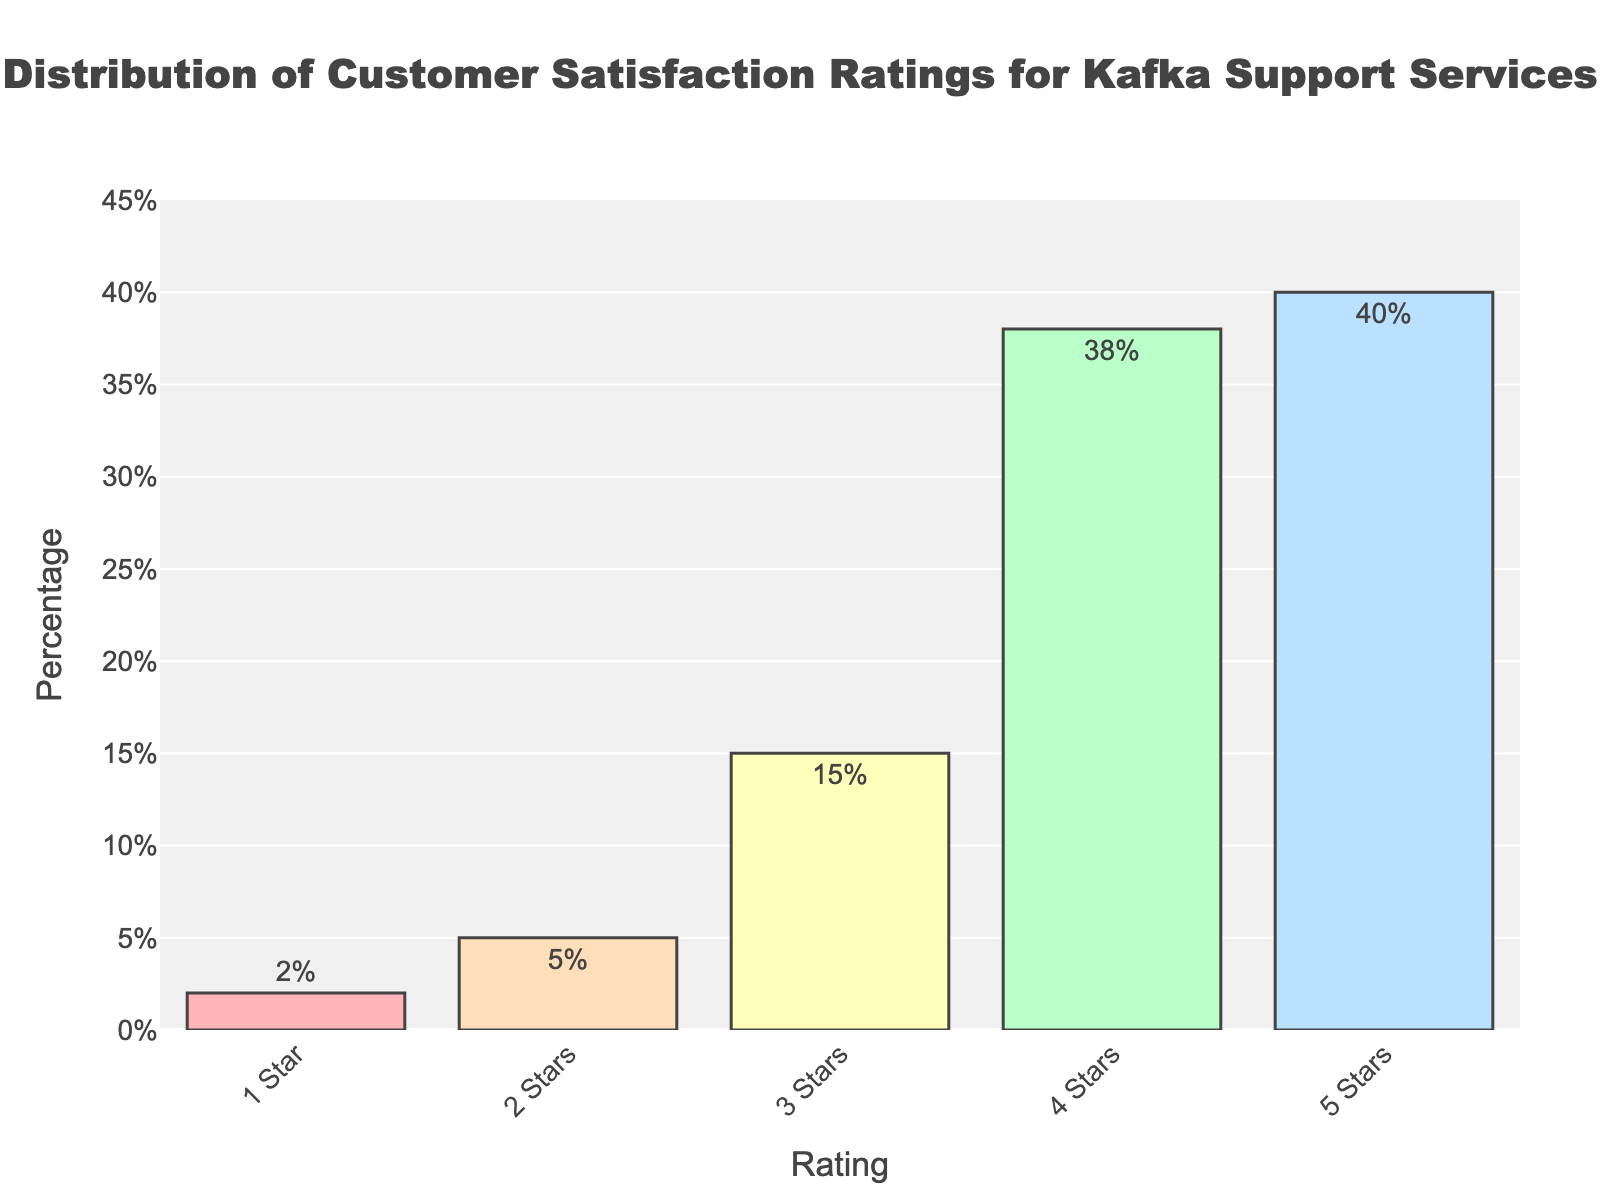what percentage of customers rated the Kafka support services with 4 stars or higher? Add the percentages of customers who rated 4 stars (38%) and 5 stars (40%). The total is 38% + 40% = 78%.
Answer: 78% Which rating received the highest percentage of customer satisfaction? The bar corresponding to the 5 Stars rating is the tallest, indicating that it received the highest percentage of customer satisfaction.
Answer: 5 Stars How many times more prevalent are 5-star ratings compared to 1-star ratings? The 5-star rating percentage is 40%, and the 1-star rating percentage is 2%. To find how many times more prevalent 5-star ratings are, divide 40% by 2%. 40 / 2 = 20.
Answer: 20 times What is the difference in customer satisfaction between 3 stars and 4 stars? Subtract the percentage of 3-star ratings (15%) from the percentage of 4-star ratings (38%). The difference is 38% - 15% = 23%.
Answer: 23% Which ratings have the same color, and what are their respective percentages? The 1-star rating bar is red, and the 4-star rating bar is green, indicating different colors. All bars have distinct colors. Thus, no two ratings have the same color.
Answer: None What is the total percentage of customers that rated the Kafka support services between 2 and 3 stars inclusive? Add the percentages of customers who rated 2 stars (5%) and 3 stars (15%). The total is 5% + 15% = 20%.
Answer: 20% If we group ratings into low (1-2 stars) and high (4-5 stars), which group has a higher percentage and by how much? Low ratings (1-2 stars) have a total percentage of 2% + 5% = 7%. High ratings (4-5 stars) have a total percentage of 38% + 40% = 78%. The difference is 78% - 7% = 71%.
Answer: High, by 71% Which color represents the 2-star rating and how does it compare to the color of the 3-star rating? The 2-star rating is orange, and the 3-star rating is yellow. Orange is generally perceived as a color that indicates warning or caution, whereas yellow is often seen as a more neutral or positive color.
Answer: Orange vs. Yellow 